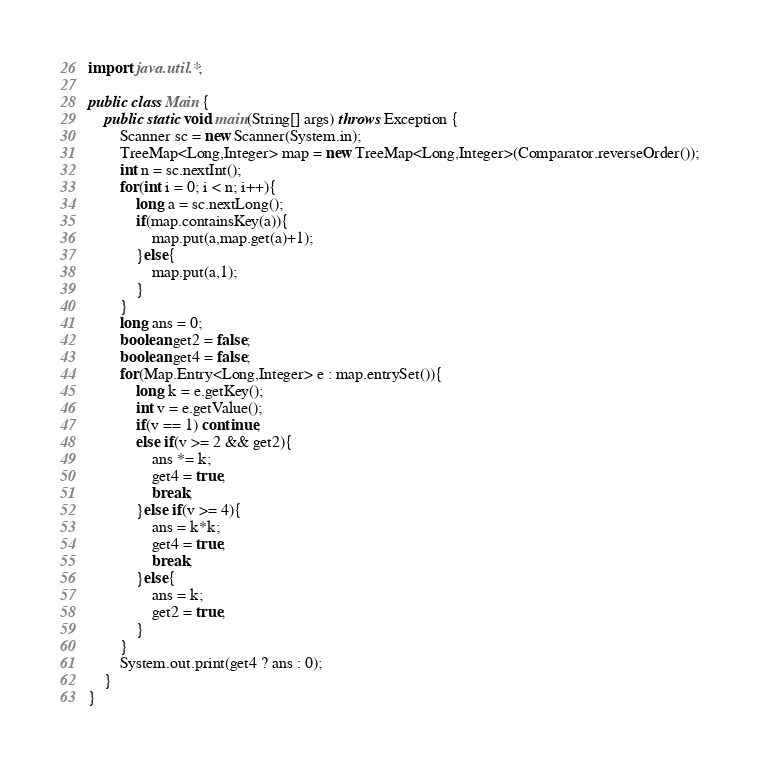<code> <loc_0><loc_0><loc_500><loc_500><_Java_>import java.util.*;

public class Main {
    public static void main(String[] args) throws Exception {
        Scanner sc = new Scanner(System.in);
        TreeMap<Long,Integer> map = new TreeMap<Long,Integer>(Comparator.reverseOrder());
        int n = sc.nextInt();
        for(int i = 0; i < n; i++){
            long a = sc.nextLong();
            if(map.containsKey(a)){
                map.put(a,map.get(a)+1);
            }else{
                map.put(a,1);
            }
        }
        long ans = 0;
        boolean get2 = false;
        boolean get4 = false;
        for(Map.Entry<Long,Integer> e : map.entrySet()){
            long k = e.getKey();
            int v = e.getValue();
            if(v == 1) continue;
            else if(v >= 2 && get2){
                ans *= k;
                get4 = true;
                break;
            }else if(v >= 4){
                ans = k*k;
                get4 = true;
                break;
            }else{
                ans = k;
                get2 = true;
            }
        }
        System.out.print(get4 ? ans : 0);
    }
}</code> 